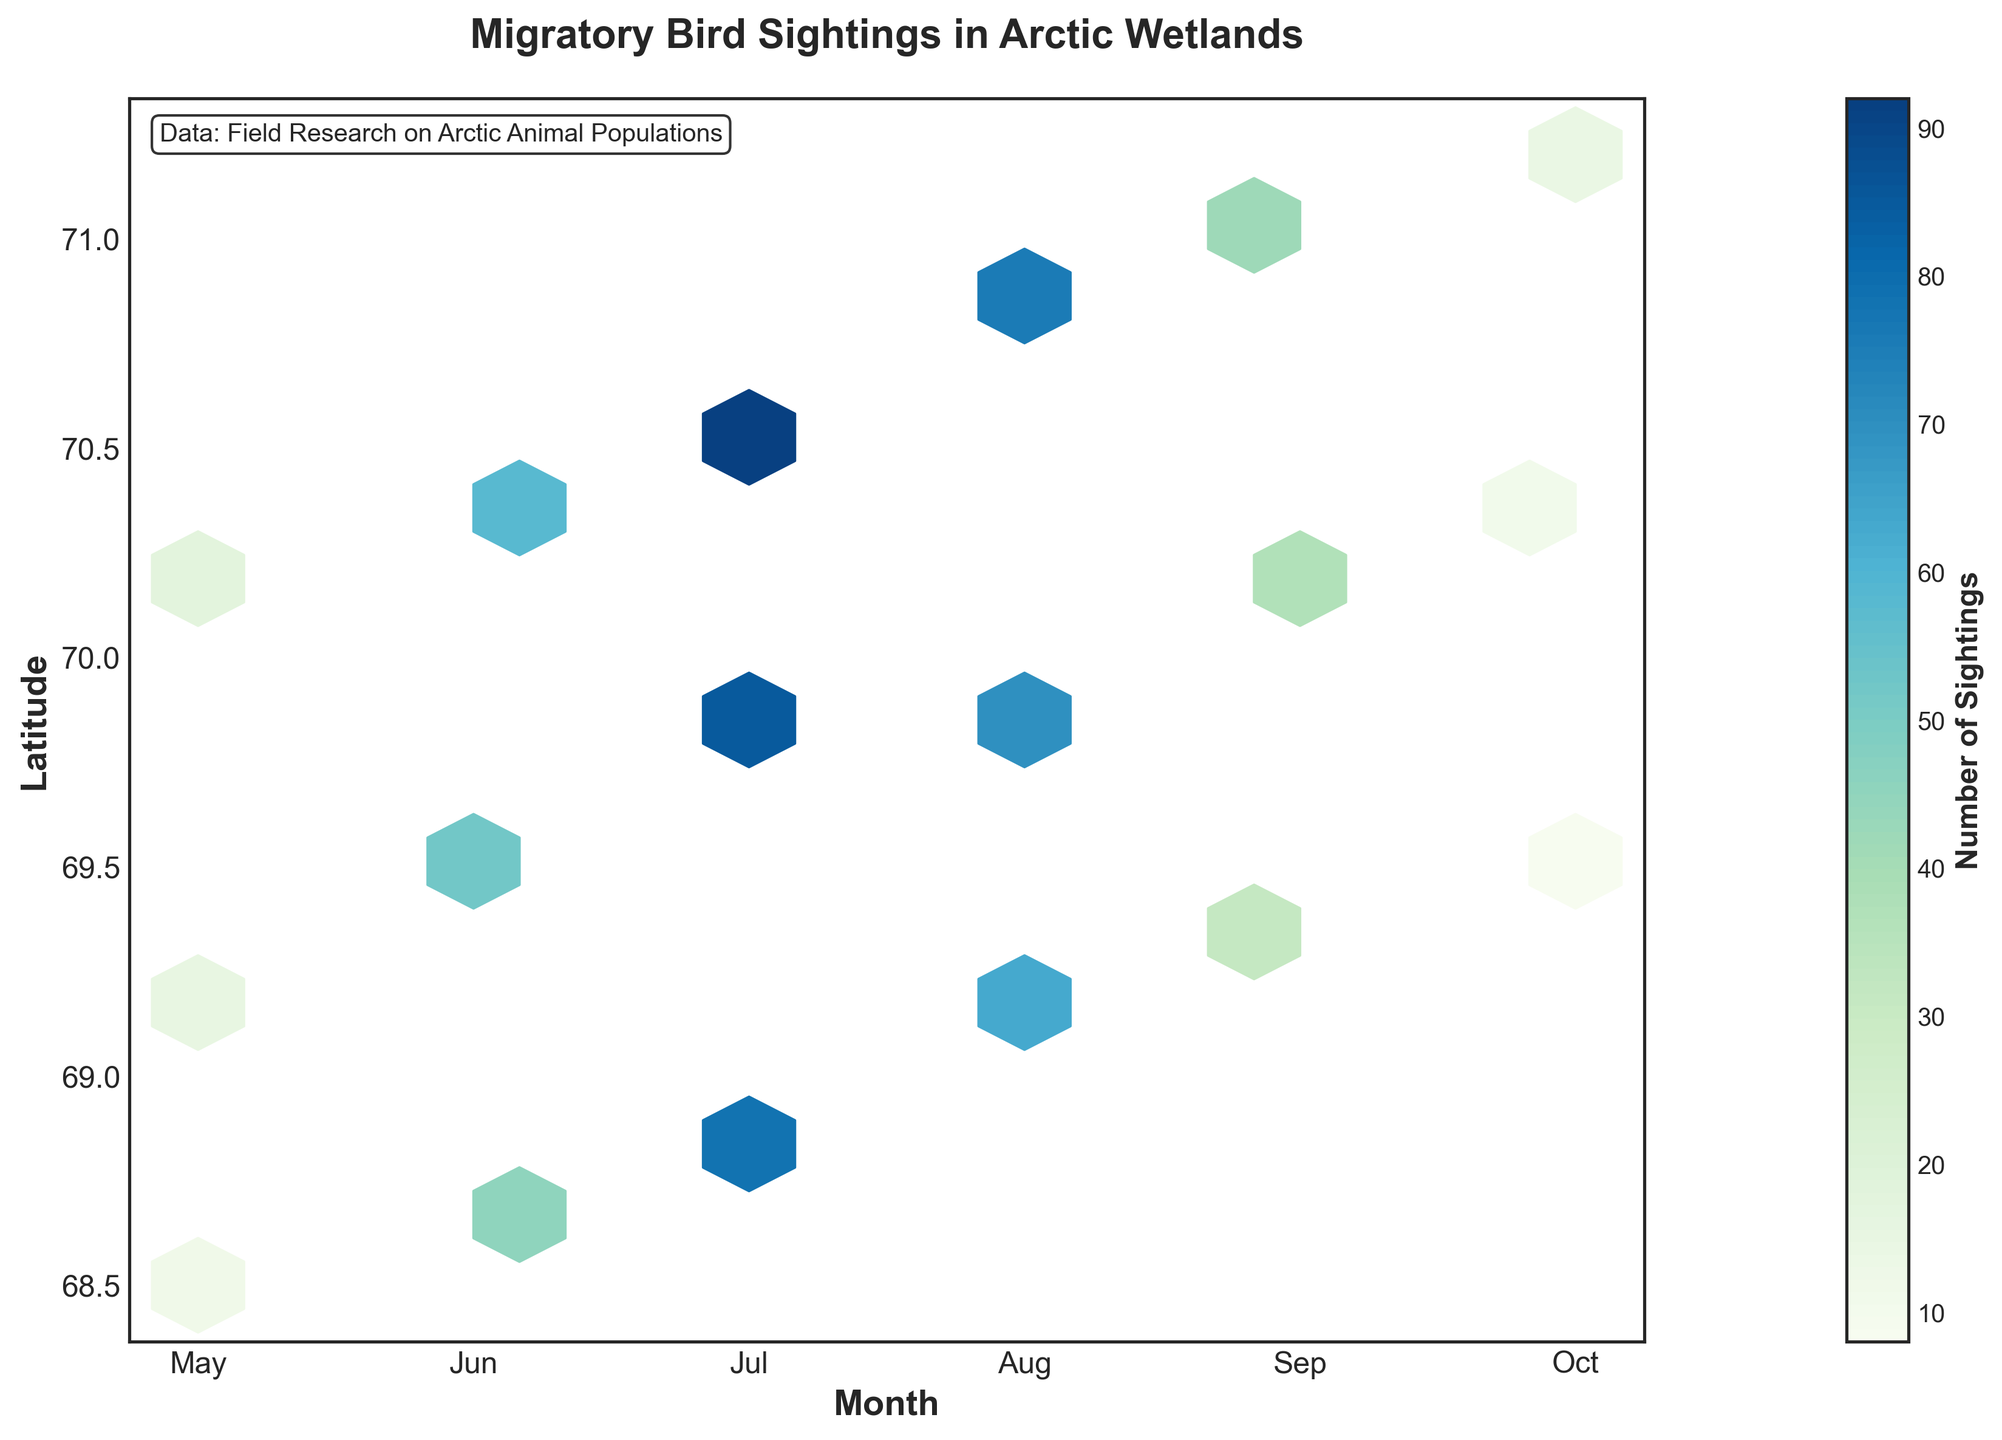what is the title of the hexbin plot? The title of the hexbin plot is given at the top of the figure. It reads "Migratory Bird Sightings in Arctic Wetlands".
Answer: Migratory Bird Sightings in Arctic Wetlands what does the color bar represent? The color bar on the right side indicates the number of sightings. The color gradient, from light to dark, represents increasing numbers of sightings.
Answer: Number of Sightings which month has the highest sightings around the latitude 70.8? Look at the color intensity around the latitude of 70.8 across different months. The darkest color, indicating the highest sightings, is seen in August.
Answer: August what are the months shown on the x-axis? The x-axis represents the months, labeled from 5 to 10. In order, they are May, June, July, August, September, and October.
Answer: May, June, July, August, September, October what is the general trend of bird sightings from May to October? The color intensity shows an increase in bird sightings from May to July, peaking in July, then decreasing from August to October.
Answer: Increases to a peak in July, then decreases which latitude ranges have the highest sightings in July? For July (x-axis labeled 7), the highest sightings are where the color is darkest, which is around 70.6 and nearby latitudes.
Answer: Around 70.6 how do the sightings in September compare to July at latitude 69.1? Compare the color intensity at latitude 69.1 in September and July. July shows darker colors (higher sightings) compared to September.
Answer: Higher in July what is the minimum number of sightings depicted on the plot? The color bar indicates the minimum value, with the lightest shade representing the minimum number of sightings, which is 1.
Answer: 1 during which month do sightings show the most concentration at latitude 69.5? Look for the darkest color around latitude 69.5; it occurs in June, indicating the most concentrated sightings.
Answer: June compare the number of sightings in May and October around latitude 69.6. By comparing the color intensity at latitude 69.6 in May and October, it's evident that May has a darker color, indicating more sightings compared to October.
Answer: More in May 